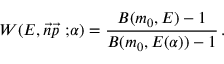<formula> <loc_0><loc_0><loc_500><loc_500>W ( E , \vec { n } \vec { p } { \ ; } \alpha ) = \frac { B ( m _ { 0 } , E ) - 1 } { B ( m _ { 0 } , E ( \alpha ) ) - 1 } \, .</formula> 